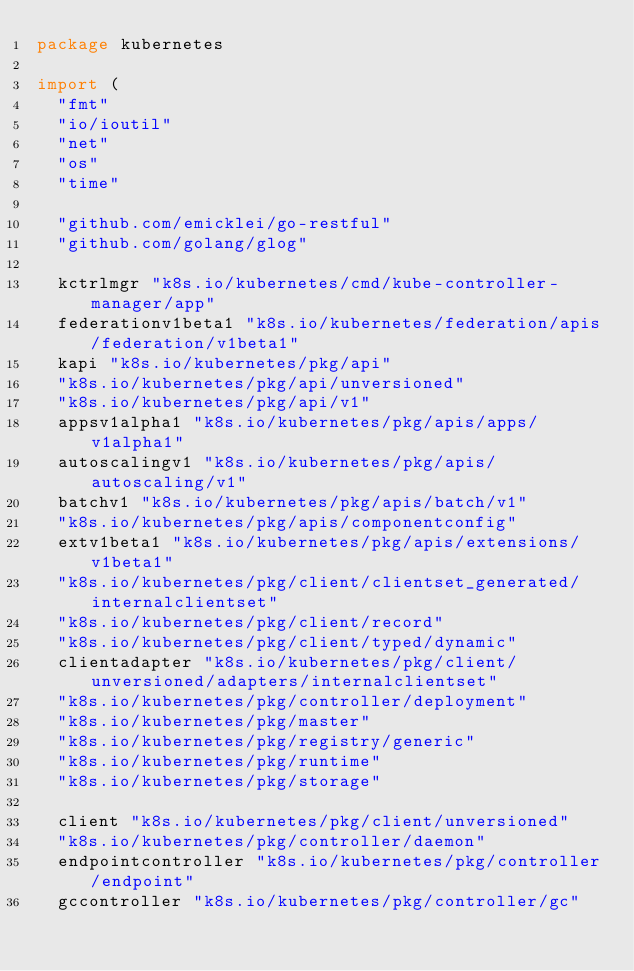<code> <loc_0><loc_0><loc_500><loc_500><_Go_>package kubernetes

import (
	"fmt"
	"io/ioutil"
	"net"
	"os"
	"time"

	"github.com/emicklei/go-restful"
	"github.com/golang/glog"

	kctrlmgr "k8s.io/kubernetes/cmd/kube-controller-manager/app"
	federationv1beta1 "k8s.io/kubernetes/federation/apis/federation/v1beta1"
	kapi "k8s.io/kubernetes/pkg/api"
	"k8s.io/kubernetes/pkg/api/unversioned"
	"k8s.io/kubernetes/pkg/api/v1"
	appsv1alpha1 "k8s.io/kubernetes/pkg/apis/apps/v1alpha1"
	autoscalingv1 "k8s.io/kubernetes/pkg/apis/autoscaling/v1"
	batchv1 "k8s.io/kubernetes/pkg/apis/batch/v1"
	"k8s.io/kubernetes/pkg/apis/componentconfig"
	extv1beta1 "k8s.io/kubernetes/pkg/apis/extensions/v1beta1"
	"k8s.io/kubernetes/pkg/client/clientset_generated/internalclientset"
	"k8s.io/kubernetes/pkg/client/record"
	"k8s.io/kubernetes/pkg/client/typed/dynamic"
	clientadapter "k8s.io/kubernetes/pkg/client/unversioned/adapters/internalclientset"
	"k8s.io/kubernetes/pkg/controller/deployment"
	"k8s.io/kubernetes/pkg/master"
	"k8s.io/kubernetes/pkg/registry/generic"
	"k8s.io/kubernetes/pkg/runtime"
	"k8s.io/kubernetes/pkg/storage"

	client "k8s.io/kubernetes/pkg/client/unversioned"
	"k8s.io/kubernetes/pkg/controller/daemon"
	endpointcontroller "k8s.io/kubernetes/pkg/controller/endpoint"
	gccontroller "k8s.io/kubernetes/pkg/controller/gc"</code> 